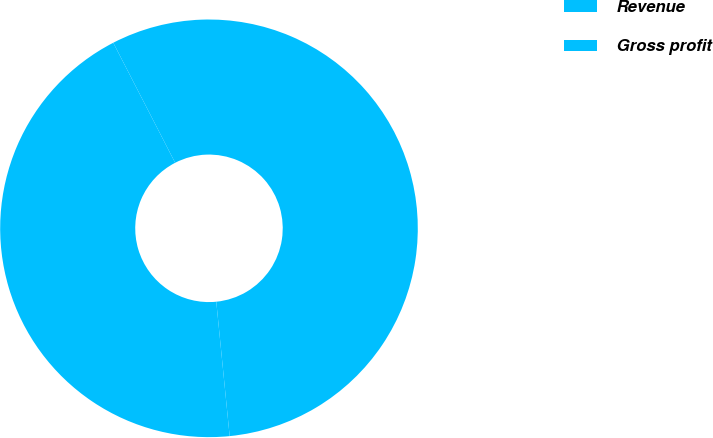Convert chart. <chart><loc_0><loc_0><loc_500><loc_500><pie_chart><fcel>Revenue<fcel>Gross profit<nl><fcel>44.0%<fcel>56.0%<nl></chart> 